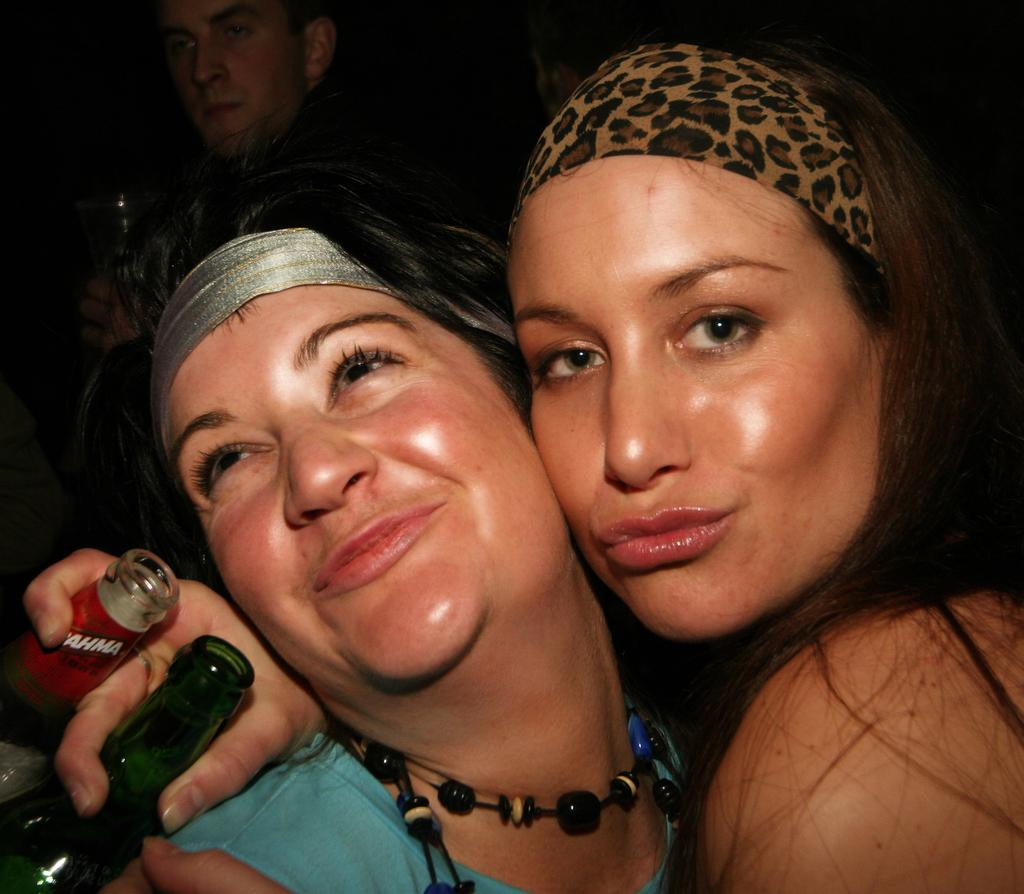How many people are in the image? There are two women in the image. What are the women doing in the image? The women are smiling and holding bottles. Can you describe the man in the background of the image? There is a man in the background of the image, but no specific details are provided about him. What type of baseball equipment can be seen in the image? There is no baseball equipment present in the image. Can you describe the bee buzzing around the women in the image? There is no bee present in the image; the women are holding bottles and smiling. 